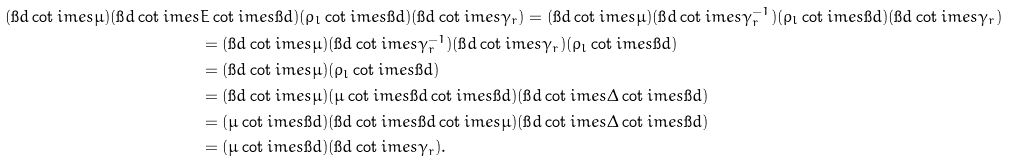Convert formula to latex. <formula><loc_0><loc_0><loc_500><loc_500>( \i d \cot i m e s \mu ) ( \i d \cot i m e s & E \cot i m e s \i d ) ( \rho _ { l } \cot i m e s \i d ) ( \i d \cot i m e s \gamma _ { r } ) = ( \i d \cot i m e s \mu ) ( \i d \cot i m e s \gamma _ { r } ^ { - 1 } ) ( \rho _ { l } \cot i m e s \i d ) ( \i d \cot i m e s \gamma _ { r } ) \\ & = ( \i d \cot i m e s \mu ) ( \i d \cot i m e s \gamma _ { r } ^ { - 1 } ) ( \i d \cot i m e s \gamma _ { r } ) ( \rho _ { l } \cot i m e s \i d ) \\ & = ( \i d \cot i m e s \mu ) ( \rho _ { l } \cot i m e s \i d ) \\ & = ( \i d \cot i m e s \mu ) ( \mu \cot i m e s \i d \cot i m e s \i d ) ( \i d \cot i m e s \Delta \cot i m e s \i d ) \\ & = ( \mu \cot i m e s \i d ) ( \i d \cot i m e s \i d \cot i m e s \mu ) ( \i d \cot i m e s \Delta \cot i m e s \i d ) \\ & = ( \mu \cot i m e s \i d ) ( \i d \cot i m e s \gamma _ { r } ) .</formula> 